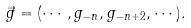<formula> <loc_0><loc_0><loc_500><loc_500>\vec { g } = ( \cdots , g _ { - n } , g _ { - n + 2 } , \cdots ) .</formula> 